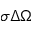<formula> <loc_0><loc_0><loc_500><loc_500>\sigma \Delta \Omega</formula> 